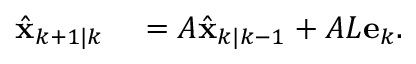<formula> <loc_0><loc_0><loc_500><loc_500>\begin{array} { r l } { \hat { x } _ { k + 1 | k } } & = A \hat { x } _ { k | k - 1 } + A L e _ { k } . } \end{array}</formula> 